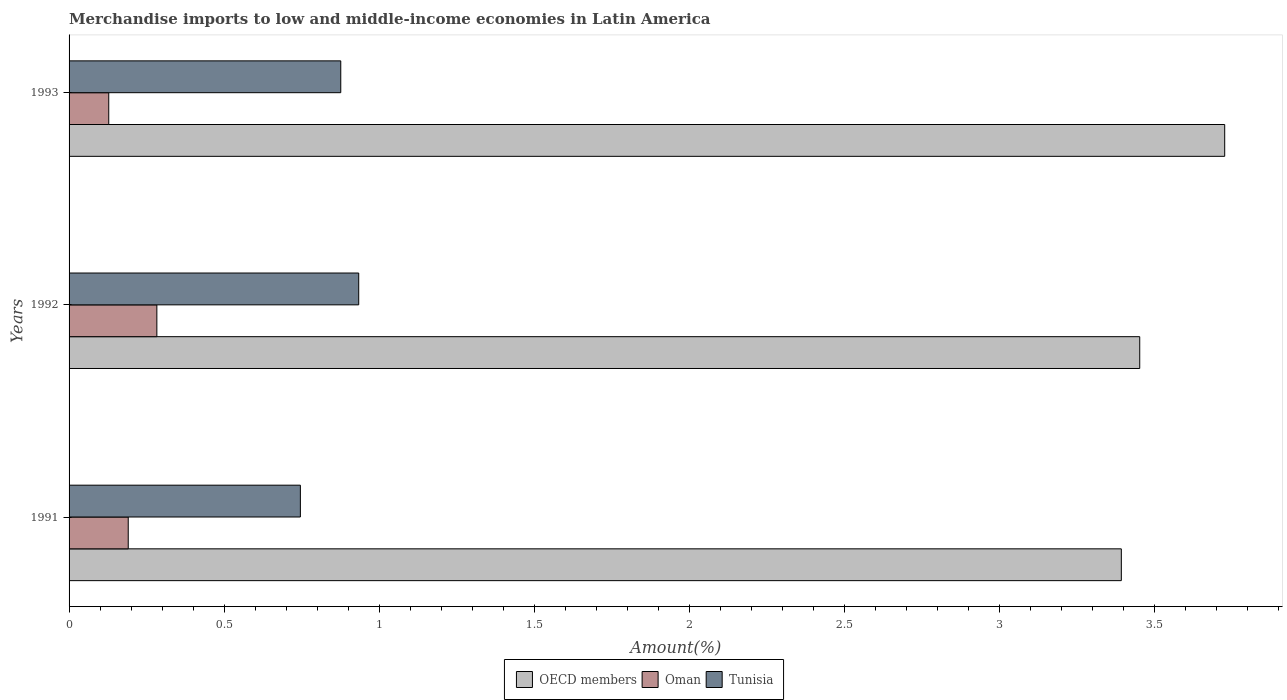Are the number of bars per tick equal to the number of legend labels?
Make the answer very short. Yes. What is the label of the 1st group of bars from the top?
Ensure brevity in your answer.  1993. What is the percentage of amount earned from merchandise imports in Tunisia in 1991?
Provide a short and direct response. 0.75. Across all years, what is the maximum percentage of amount earned from merchandise imports in Tunisia?
Your response must be concise. 0.93. Across all years, what is the minimum percentage of amount earned from merchandise imports in OECD members?
Your answer should be very brief. 3.39. In which year was the percentage of amount earned from merchandise imports in Tunisia maximum?
Make the answer very short. 1992. In which year was the percentage of amount earned from merchandise imports in OECD members minimum?
Your response must be concise. 1991. What is the total percentage of amount earned from merchandise imports in Tunisia in the graph?
Offer a terse response. 2.56. What is the difference between the percentage of amount earned from merchandise imports in Oman in 1992 and that in 1993?
Give a very brief answer. 0.16. What is the difference between the percentage of amount earned from merchandise imports in Tunisia in 1992 and the percentage of amount earned from merchandise imports in OECD members in 1993?
Your answer should be compact. -2.79. What is the average percentage of amount earned from merchandise imports in Tunisia per year?
Give a very brief answer. 0.85. In the year 1993, what is the difference between the percentage of amount earned from merchandise imports in OECD members and percentage of amount earned from merchandise imports in Oman?
Offer a very short reply. 3.6. In how many years, is the percentage of amount earned from merchandise imports in Oman greater than 2.3 %?
Give a very brief answer. 0. What is the ratio of the percentage of amount earned from merchandise imports in OECD members in 1991 to that in 1993?
Make the answer very short. 0.91. What is the difference between the highest and the second highest percentage of amount earned from merchandise imports in OECD members?
Offer a very short reply. 0.27. What is the difference between the highest and the lowest percentage of amount earned from merchandise imports in Tunisia?
Keep it short and to the point. 0.19. What does the 1st bar from the top in 1992 represents?
Ensure brevity in your answer.  Tunisia. What does the 3rd bar from the bottom in 1992 represents?
Make the answer very short. Tunisia. How many bars are there?
Provide a succinct answer. 9. What is the difference between two consecutive major ticks on the X-axis?
Provide a short and direct response. 0.5. Are the values on the major ticks of X-axis written in scientific E-notation?
Ensure brevity in your answer.  No. Does the graph contain any zero values?
Keep it short and to the point. No. Does the graph contain grids?
Your response must be concise. No. Where does the legend appear in the graph?
Give a very brief answer. Bottom center. What is the title of the graph?
Provide a succinct answer. Merchandise imports to low and middle-income economies in Latin America. What is the label or title of the X-axis?
Offer a terse response. Amount(%). What is the Amount(%) in OECD members in 1991?
Give a very brief answer. 3.39. What is the Amount(%) in Oman in 1991?
Provide a succinct answer. 0.19. What is the Amount(%) in Tunisia in 1991?
Make the answer very short. 0.75. What is the Amount(%) of OECD members in 1992?
Provide a succinct answer. 3.45. What is the Amount(%) of Oman in 1992?
Offer a very short reply. 0.28. What is the Amount(%) of Tunisia in 1992?
Ensure brevity in your answer.  0.93. What is the Amount(%) of OECD members in 1993?
Offer a very short reply. 3.73. What is the Amount(%) of Oman in 1993?
Your answer should be compact. 0.13. What is the Amount(%) of Tunisia in 1993?
Your answer should be compact. 0.88. Across all years, what is the maximum Amount(%) in OECD members?
Your answer should be very brief. 3.73. Across all years, what is the maximum Amount(%) of Oman?
Your answer should be compact. 0.28. Across all years, what is the maximum Amount(%) of Tunisia?
Offer a terse response. 0.93. Across all years, what is the minimum Amount(%) of OECD members?
Ensure brevity in your answer.  3.39. Across all years, what is the minimum Amount(%) in Oman?
Provide a succinct answer. 0.13. Across all years, what is the minimum Amount(%) in Tunisia?
Ensure brevity in your answer.  0.75. What is the total Amount(%) of OECD members in the graph?
Keep it short and to the point. 10.58. What is the total Amount(%) of Oman in the graph?
Offer a very short reply. 0.6. What is the total Amount(%) in Tunisia in the graph?
Ensure brevity in your answer.  2.56. What is the difference between the Amount(%) of OECD members in 1991 and that in 1992?
Your answer should be compact. -0.06. What is the difference between the Amount(%) in Oman in 1991 and that in 1992?
Offer a very short reply. -0.09. What is the difference between the Amount(%) of Tunisia in 1991 and that in 1992?
Your answer should be compact. -0.19. What is the difference between the Amount(%) in OECD members in 1991 and that in 1993?
Provide a succinct answer. -0.33. What is the difference between the Amount(%) of Oman in 1991 and that in 1993?
Ensure brevity in your answer.  0.06. What is the difference between the Amount(%) in Tunisia in 1991 and that in 1993?
Make the answer very short. -0.13. What is the difference between the Amount(%) in OECD members in 1992 and that in 1993?
Your answer should be compact. -0.27. What is the difference between the Amount(%) in Oman in 1992 and that in 1993?
Give a very brief answer. 0.16. What is the difference between the Amount(%) of Tunisia in 1992 and that in 1993?
Offer a terse response. 0.06. What is the difference between the Amount(%) of OECD members in 1991 and the Amount(%) of Oman in 1992?
Provide a short and direct response. 3.11. What is the difference between the Amount(%) in OECD members in 1991 and the Amount(%) in Tunisia in 1992?
Your answer should be compact. 2.46. What is the difference between the Amount(%) of Oman in 1991 and the Amount(%) of Tunisia in 1992?
Provide a short and direct response. -0.74. What is the difference between the Amount(%) of OECD members in 1991 and the Amount(%) of Oman in 1993?
Ensure brevity in your answer.  3.27. What is the difference between the Amount(%) of OECD members in 1991 and the Amount(%) of Tunisia in 1993?
Offer a very short reply. 2.52. What is the difference between the Amount(%) of Oman in 1991 and the Amount(%) of Tunisia in 1993?
Provide a succinct answer. -0.69. What is the difference between the Amount(%) of OECD members in 1992 and the Amount(%) of Oman in 1993?
Your response must be concise. 3.33. What is the difference between the Amount(%) in OECD members in 1992 and the Amount(%) in Tunisia in 1993?
Your answer should be very brief. 2.58. What is the difference between the Amount(%) of Oman in 1992 and the Amount(%) of Tunisia in 1993?
Make the answer very short. -0.59. What is the average Amount(%) in OECD members per year?
Provide a succinct answer. 3.53. What is the average Amount(%) of Oman per year?
Your response must be concise. 0.2. What is the average Amount(%) of Tunisia per year?
Your answer should be compact. 0.85. In the year 1991, what is the difference between the Amount(%) in OECD members and Amount(%) in Oman?
Your answer should be compact. 3.2. In the year 1991, what is the difference between the Amount(%) in OECD members and Amount(%) in Tunisia?
Make the answer very short. 2.65. In the year 1991, what is the difference between the Amount(%) in Oman and Amount(%) in Tunisia?
Your response must be concise. -0.56. In the year 1992, what is the difference between the Amount(%) of OECD members and Amount(%) of Oman?
Provide a succinct answer. 3.17. In the year 1992, what is the difference between the Amount(%) of OECD members and Amount(%) of Tunisia?
Make the answer very short. 2.52. In the year 1992, what is the difference between the Amount(%) of Oman and Amount(%) of Tunisia?
Your answer should be very brief. -0.65. In the year 1993, what is the difference between the Amount(%) of OECD members and Amount(%) of Oman?
Your response must be concise. 3.6. In the year 1993, what is the difference between the Amount(%) in OECD members and Amount(%) in Tunisia?
Provide a short and direct response. 2.85. In the year 1993, what is the difference between the Amount(%) of Oman and Amount(%) of Tunisia?
Give a very brief answer. -0.75. What is the ratio of the Amount(%) in OECD members in 1991 to that in 1992?
Your answer should be compact. 0.98. What is the ratio of the Amount(%) in Oman in 1991 to that in 1992?
Your response must be concise. 0.67. What is the ratio of the Amount(%) of Tunisia in 1991 to that in 1992?
Ensure brevity in your answer.  0.8. What is the ratio of the Amount(%) in OECD members in 1991 to that in 1993?
Provide a succinct answer. 0.91. What is the ratio of the Amount(%) in Oman in 1991 to that in 1993?
Offer a very short reply. 1.49. What is the ratio of the Amount(%) of Tunisia in 1991 to that in 1993?
Offer a very short reply. 0.85. What is the ratio of the Amount(%) in OECD members in 1992 to that in 1993?
Offer a terse response. 0.93. What is the ratio of the Amount(%) in Oman in 1992 to that in 1993?
Give a very brief answer. 2.21. What is the ratio of the Amount(%) of Tunisia in 1992 to that in 1993?
Your answer should be compact. 1.07. What is the difference between the highest and the second highest Amount(%) in OECD members?
Your response must be concise. 0.27. What is the difference between the highest and the second highest Amount(%) in Oman?
Keep it short and to the point. 0.09. What is the difference between the highest and the second highest Amount(%) in Tunisia?
Your response must be concise. 0.06. What is the difference between the highest and the lowest Amount(%) in OECD members?
Your answer should be very brief. 0.33. What is the difference between the highest and the lowest Amount(%) of Oman?
Ensure brevity in your answer.  0.16. What is the difference between the highest and the lowest Amount(%) in Tunisia?
Your answer should be very brief. 0.19. 